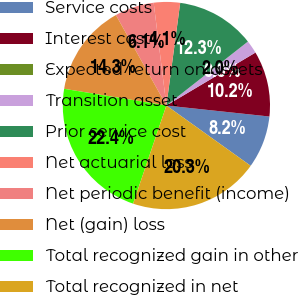Convert chart. <chart><loc_0><loc_0><loc_500><loc_500><pie_chart><fcel>Service costs<fcel>Interest cost<fcel>Expected return on assets<fcel>Transition asset<fcel>Prior service cost<fcel>Net actuarial loss<fcel>Net periodic benefit (income)<fcel>Net (gain) loss<fcel>Total recognized gain in other<fcel>Total recognized in net<nl><fcel>8.19%<fcel>10.23%<fcel>0.0%<fcel>2.05%<fcel>12.28%<fcel>4.09%<fcel>6.14%<fcel>14.32%<fcel>22.37%<fcel>20.33%<nl></chart> 